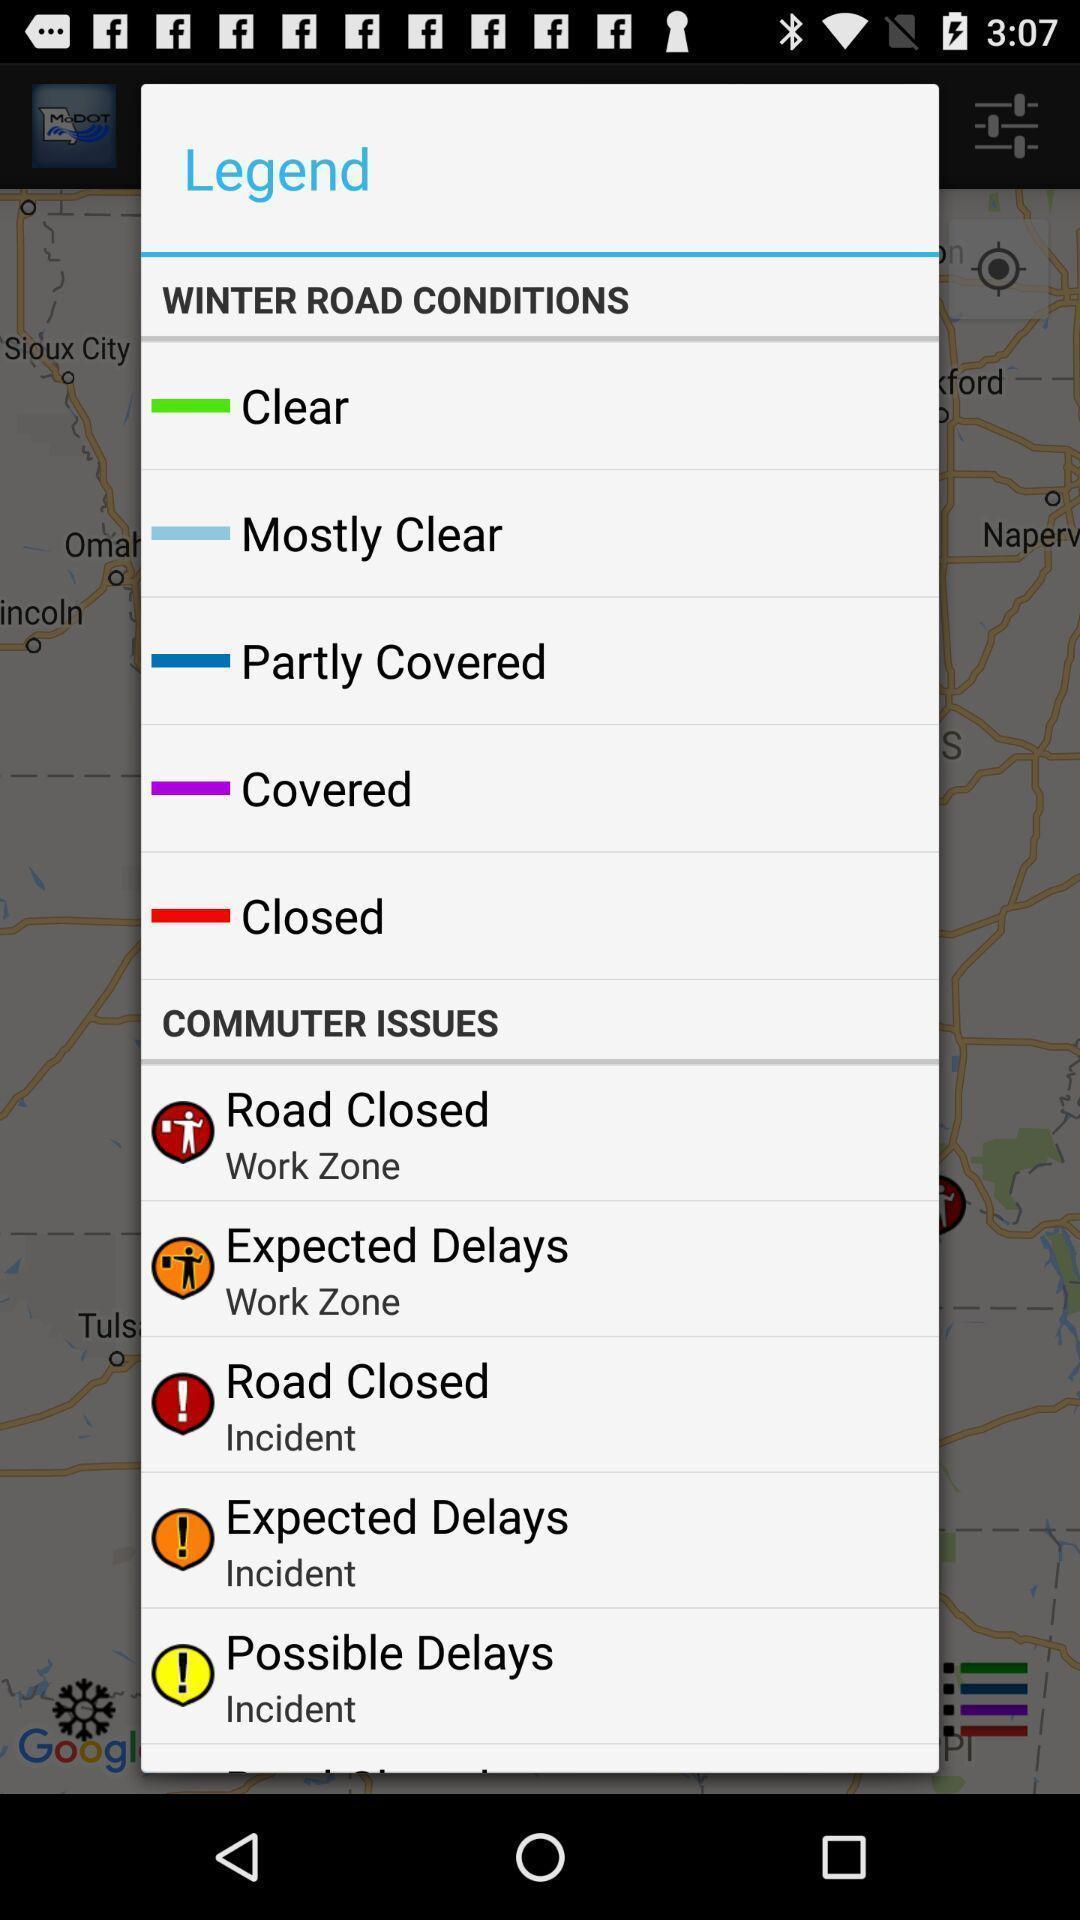Describe the visual elements of this screenshot. Pop-up displaying the condition of the roads and their issues. 